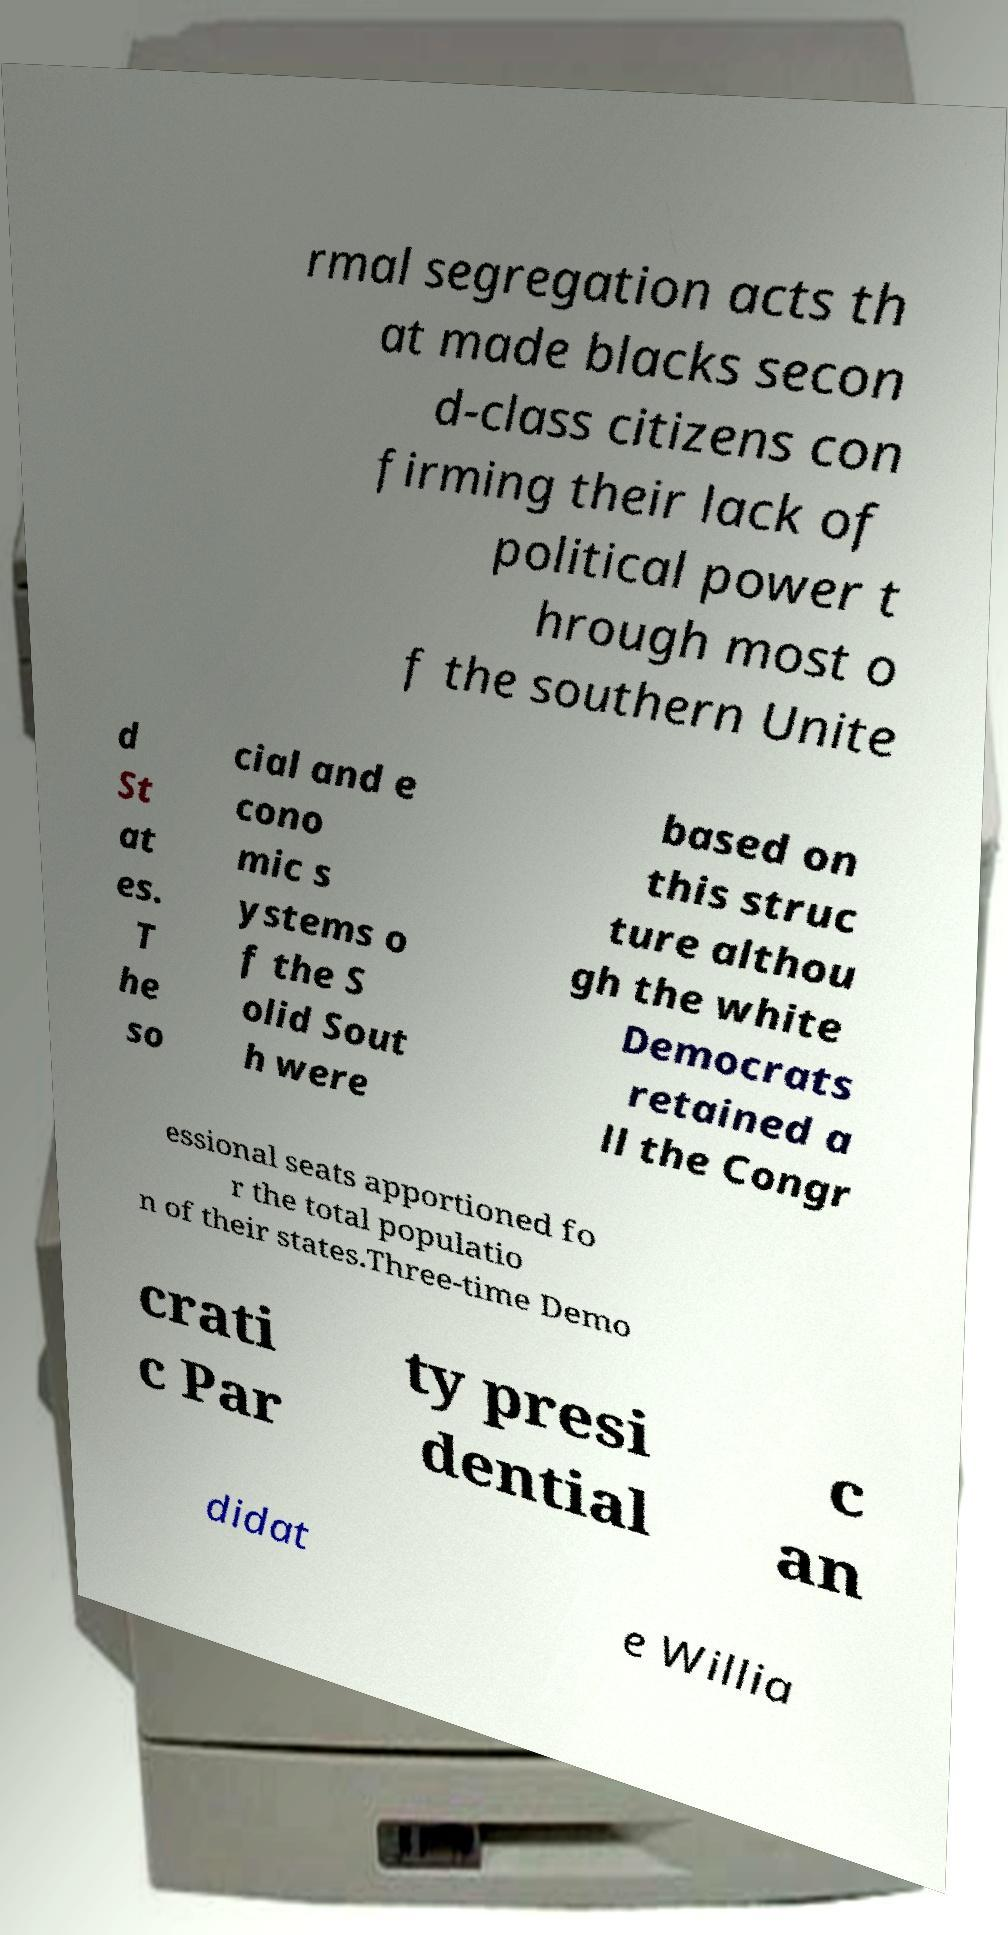Can you read and provide the text displayed in the image?This photo seems to have some interesting text. Can you extract and type it out for me? rmal segregation acts th at made blacks secon d-class citizens con firming their lack of political power t hrough most o f the southern Unite d St at es. T he so cial and e cono mic s ystems o f the S olid Sout h were based on this struc ture althou gh the white Democrats retained a ll the Congr essional seats apportioned fo r the total populatio n of their states.Three-time Demo crati c Par ty presi dential c an didat e Willia 